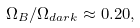<formula> <loc_0><loc_0><loc_500><loc_500>\Omega _ { B } / \Omega _ { d a r k } \approx 0 . 2 0 ,</formula> 